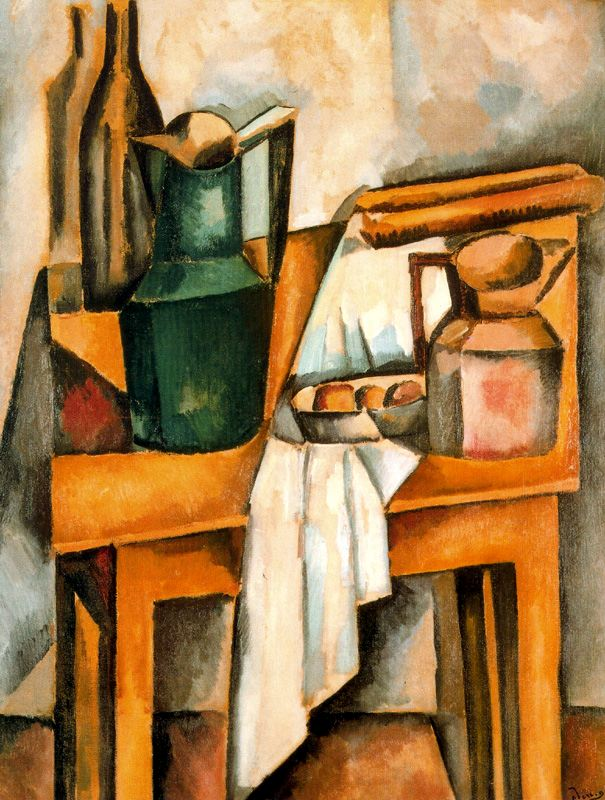Explain the visual content of the image in great detail. The image is a dynamic Cubist painting, characterized by its fragmentations and abstract forms. The composition centers around a still-life setup on a table, featuring a green vase, a blue book, and an earth-toned jar with intriguing geometric fragmentation, a hallmark of Cubism. The vase and book, likely symbolic of natural and intellectual pursuits, contrast sharply against the muted tones of the background, which includes a subtly depicted brown chair. The use of light and shadow creates an intriguing interplay, adding depth and volume to the forms. The tablecloth's folds introduce a sense of movement, enhancing the static objects with a textile texture. The artwork, signed 'Dufy', showcases a unique interpretation of the Cubist style through its simplified palette and clear composition. 